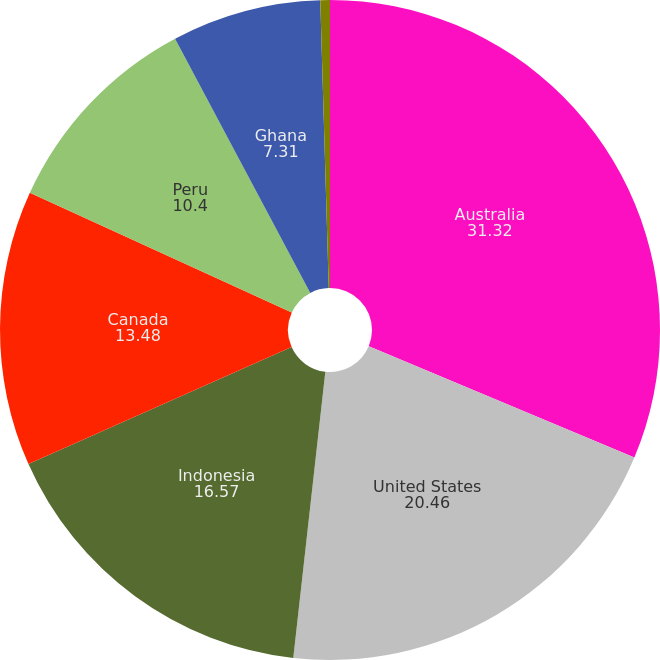<chart> <loc_0><loc_0><loc_500><loc_500><pie_chart><fcel>Australia<fcel>United States<fcel>Indonesia<fcel>Canada<fcel>Peru<fcel>Ghana<fcel>Other<nl><fcel>31.32%<fcel>20.46%<fcel>16.57%<fcel>13.48%<fcel>10.4%<fcel>7.31%<fcel>0.47%<nl></chart> 